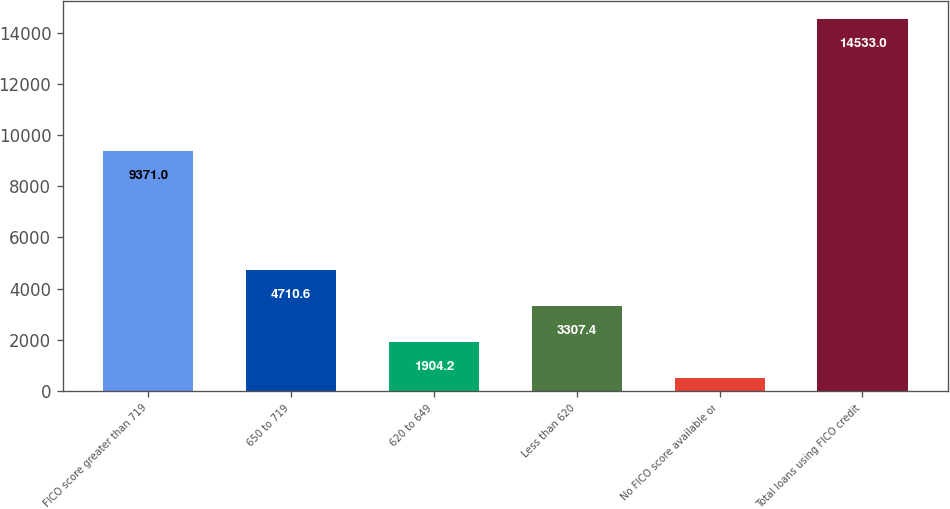Convert chart to OTSL. <chart><loc_0><loc_0><loc_500><loc_500><bar_chart><fcel>FICO score greater than 719<fcel>650 to 719<fcel>620 to 649<fcel>Less than 620<fcel>No FICO score available or<fcel>Total loans using FICO credit<nl><fcel>9371<fcel>4710.6<fcel>1904.2<fcel>3307.4<fcel>501<fcel>14533<nl></chart> 